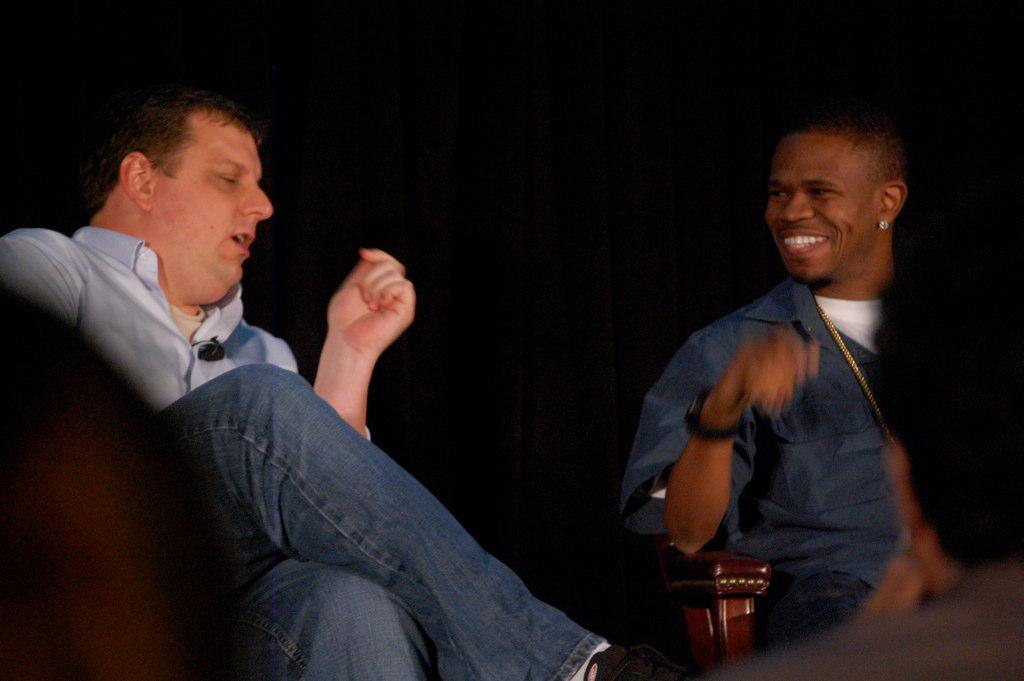Please provide a concise description of this image. In this picture we can see some people sitting on chairs and a man in the shirt is explaining something and another man is smiling. Behind the people there is a dark background. 